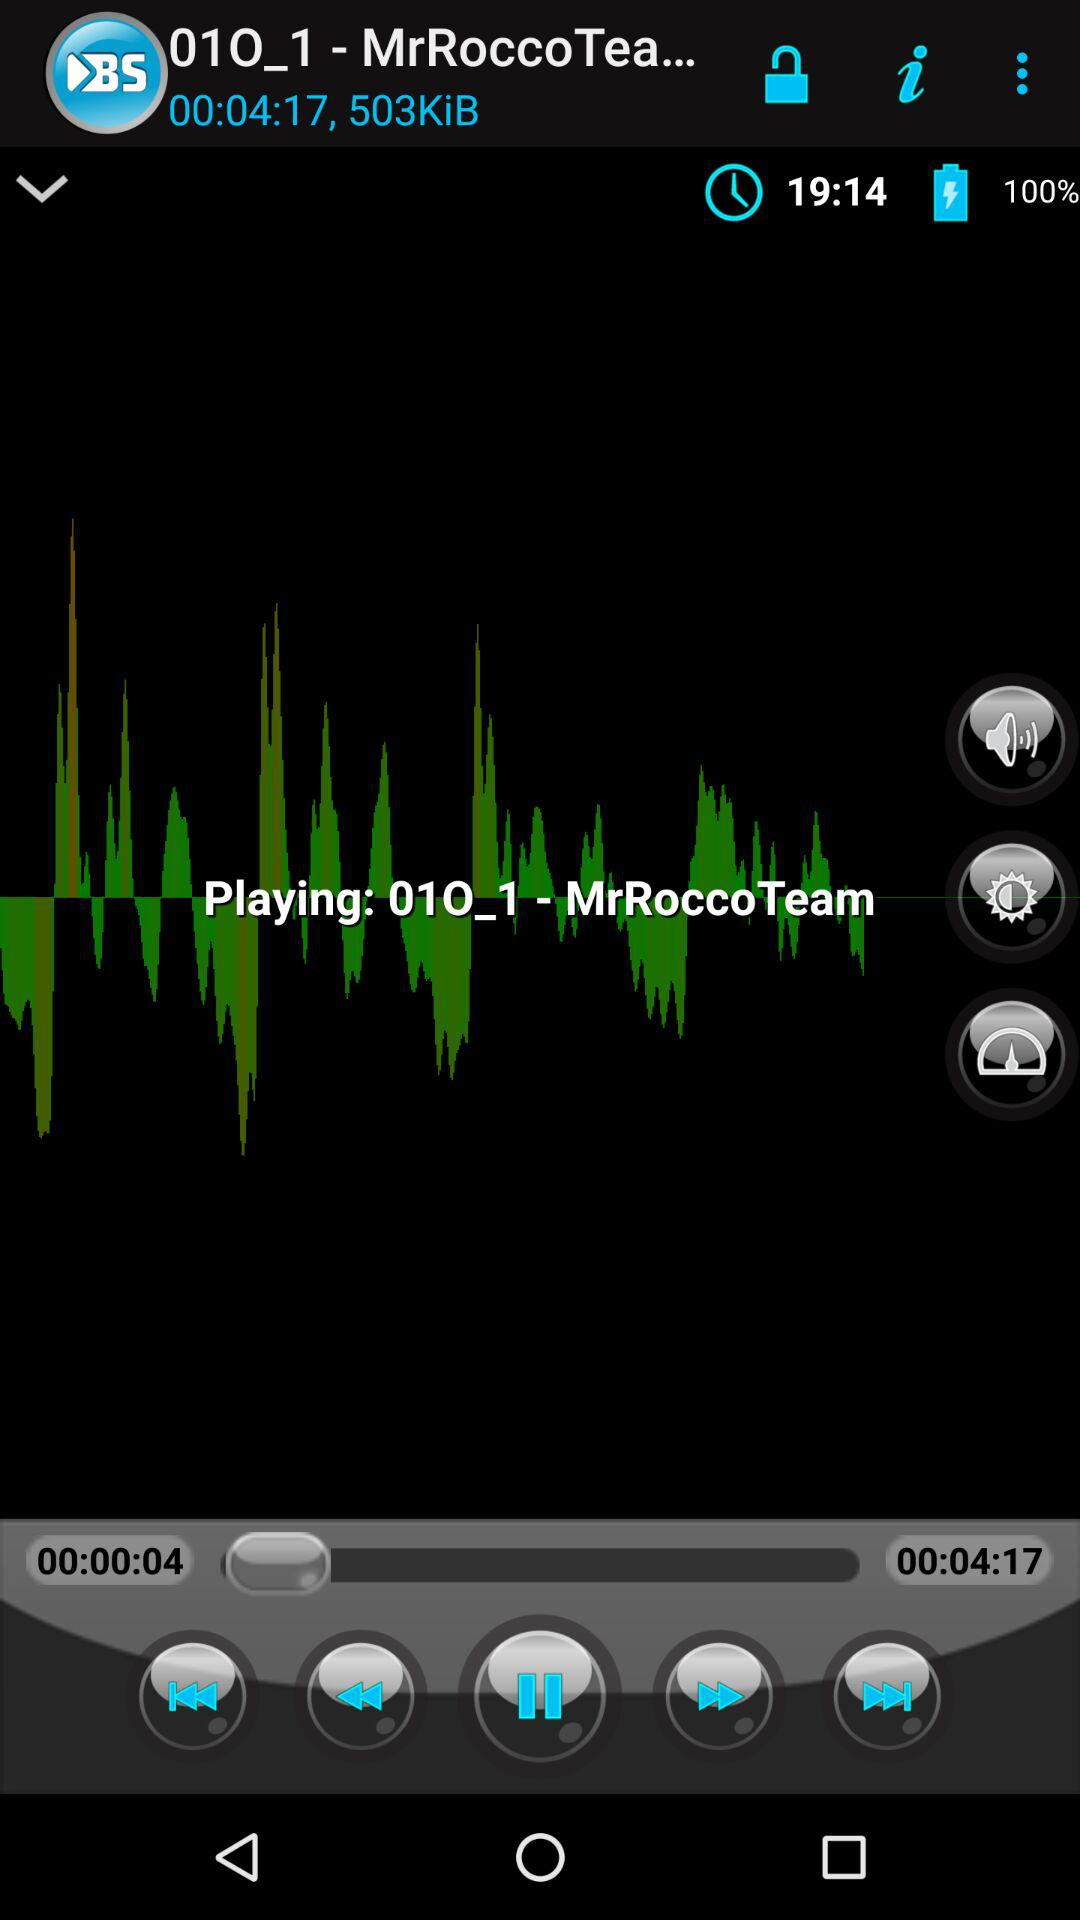How much battery is left? The battery is 100%. 